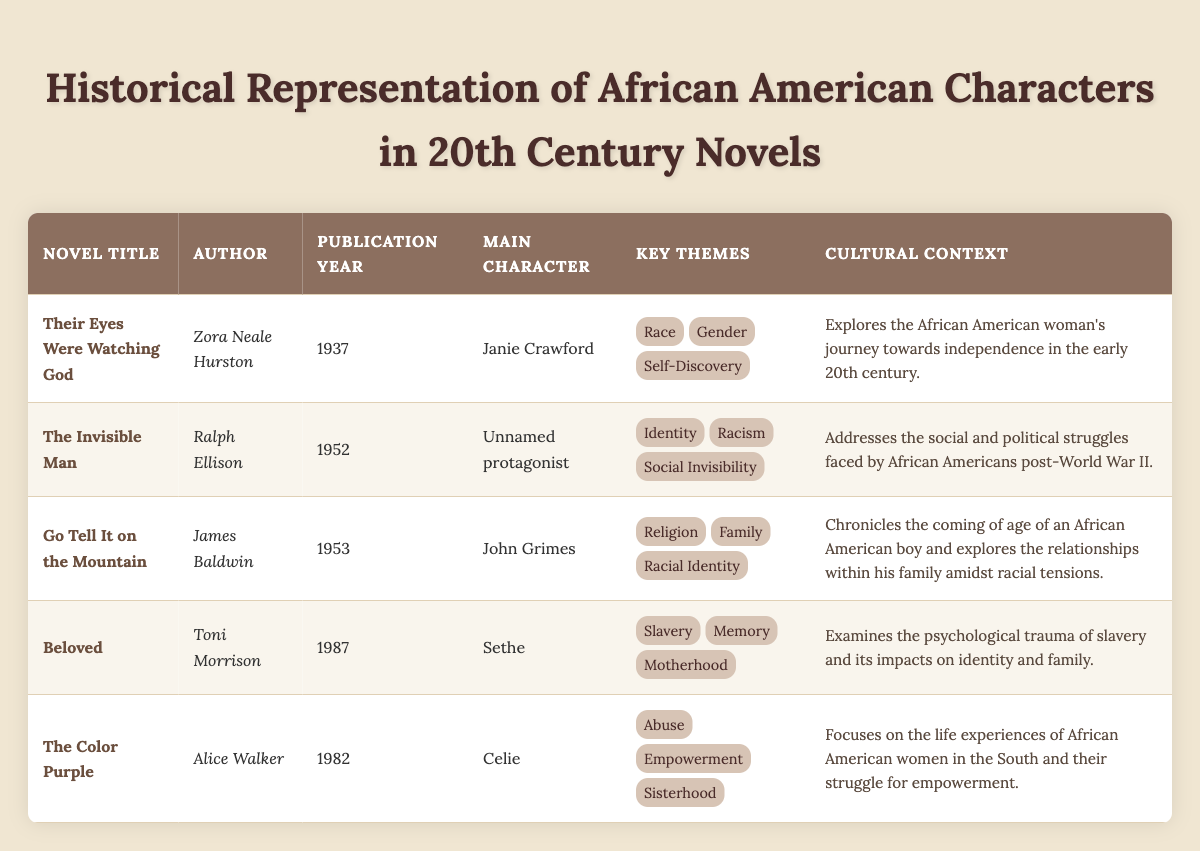What is the publication year of "Beloved"? The publication year of "Beloved," as indicated in the table, is 1987.
Answer: 1987 Who is the main character in "The Color Purple"? According to the table, the main character in "The Color Purple" is Celie.
Answer: Celie What are the key themes of "Their Eyes Were Watching God"? The table lists the key themes of "Their Eyes Were Watching God" as Race, Gender, and Self-Discovery.
Answer: Race, Gender, Self-Discovery Is "The Invisible Man" published before 1960? The table shows that "The Invisible Man" was published in 1952, which is before 1960.
Answer: Yes Which novel focuses on the life experiences of African American women in the South? The description in the table indicates that "The Color Purple" focuses on the life experiences of African American women in the South.
Answer: The Color Purple How many novels mentioned have motherhood as a key theme? The table lists the key themes for each novel, and only "Beloved" has motherhood as a key theme. Therefore, there is 1 novel with this theme.
Answer: 1 Which author wrote about family relationships amidst racial tensions? The table states that James Baldwin wrote "Go Tell It on the Mountain," which focuses on family relationships amidst racial tensions.
Answer: James Baldwin What is the cultural context of "Go Tell It on the Mountain"? The table outlines that "Go Tell It on the Mountain" chronicles the coming of age of an African American boy and explores relationships within his family amidst racial tensions.
Answer: Relationships within family amidst racial tensions Which of the listed novels was published last? By examining the publication years listed in the table, "Beloved" (1987) is the most recent publication compared to the others.
Answer: Beloved 